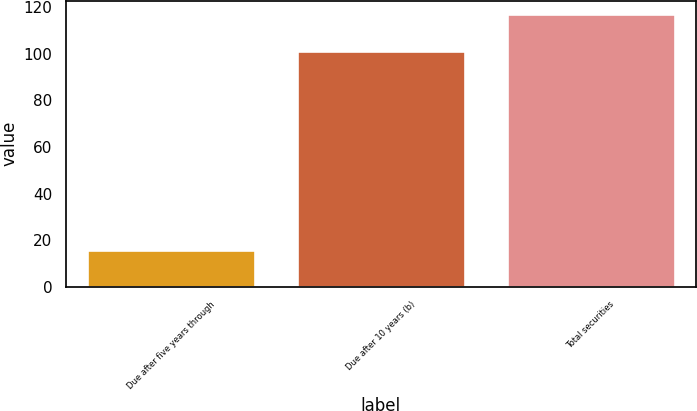<chart> <loc_0><loc_0><loc_500><loc_500><bar_chart><fcel>Due after five years through<fcel>Due after 10 years (b)<fcel>Total securities<nl><fcel>16<fcel>101<fcel>117<nl></chart> 